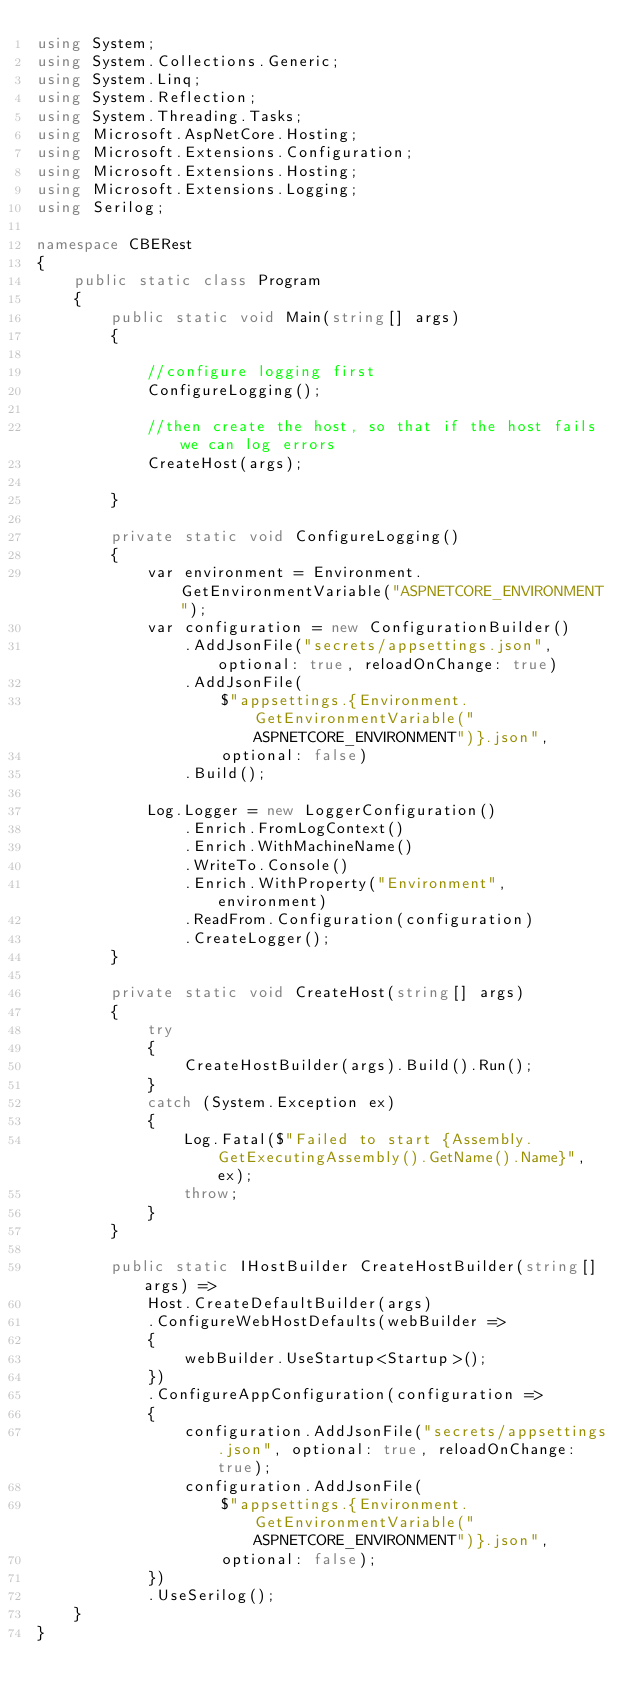<code> <loc_0><loc_0><loc_500><loc_500><_C#_>using System;
using System.Collections.Generic;
using System.Linq;
using System.Reflection;
using System.Threading.Tasks;
using Microsoft.AspNetCore.Hosting;
using Microsoft.Extensions.Configuration;
using Microsoft.Extensions.Hosting;
using Microsoft.Extensions.Logging;
using Serilog;

namespace CBERest
{
    public static class Program
    {
        public static void Main(string[] args)
        {

            //configure logging first
            ConfigureLogging();

            //then create the host, so that if the host fails we can log errors
            CreateHost(args);
            
        }

        private static void ConfigureLogging()
        {
            var environment = Environment.GetEnvironmentVariable("ASPNETCORE_ENVIRONMENT");
            var configuration = new ConfigurationBuilder()
                .AddJsonFile("secrets/appsettings.json", optional: true, reloadOnChange: true)
                .AddJsonFile(
                    $"appsettings.{Environment.GetEnvironmentVariable("ASPNETCORE_ENVIRONMENT")}.json",
                    optional: false)
                .Build();

            Log.Logger = new LoggerConfiguration()
                .Enrich.FromLogContext()
                .Enrich.WithMachineName()
                .WriteTo.Console()
                .Enrich.WithProperty("Environment", environment)
                .ReadFrom.Configuration(configuration)
                .CreateLogger();
        }

        private static void CreateHost(string[] args)
        {
            try
            {
                CreateHostBuilder(args).Build().Run();
            }
            catch (System.Exception ex)
            {
                Log.Fatal($"Failed to start {Assembly.GetExecutingAssembly().GetName().Name}", ex);
                throw;
            }
        }

        public static IHostBuilder CreateHostBuilder(string[] args) =>
            Host.CreateDefaultBuilder(args)
            .ConfigureWebHostDefaults(webBuilder =>
            {
                webBuilder.UseStartup<Startup>();
            })
            .ConfigureAppConfiguration(configuration =>
            {
                configuration.AddJsonFile("secrets/appsettings.json", optional: true, reloadOnChange: true);
                configuration.AddJsonFile(
                    $"appsettings.{Environment.GetEnvironmentVariable("ASPNETCORE_ENVIRONMENT")}.json",
                    optional: false);
            })
            .UseSerilog();
    }
}
</code> 